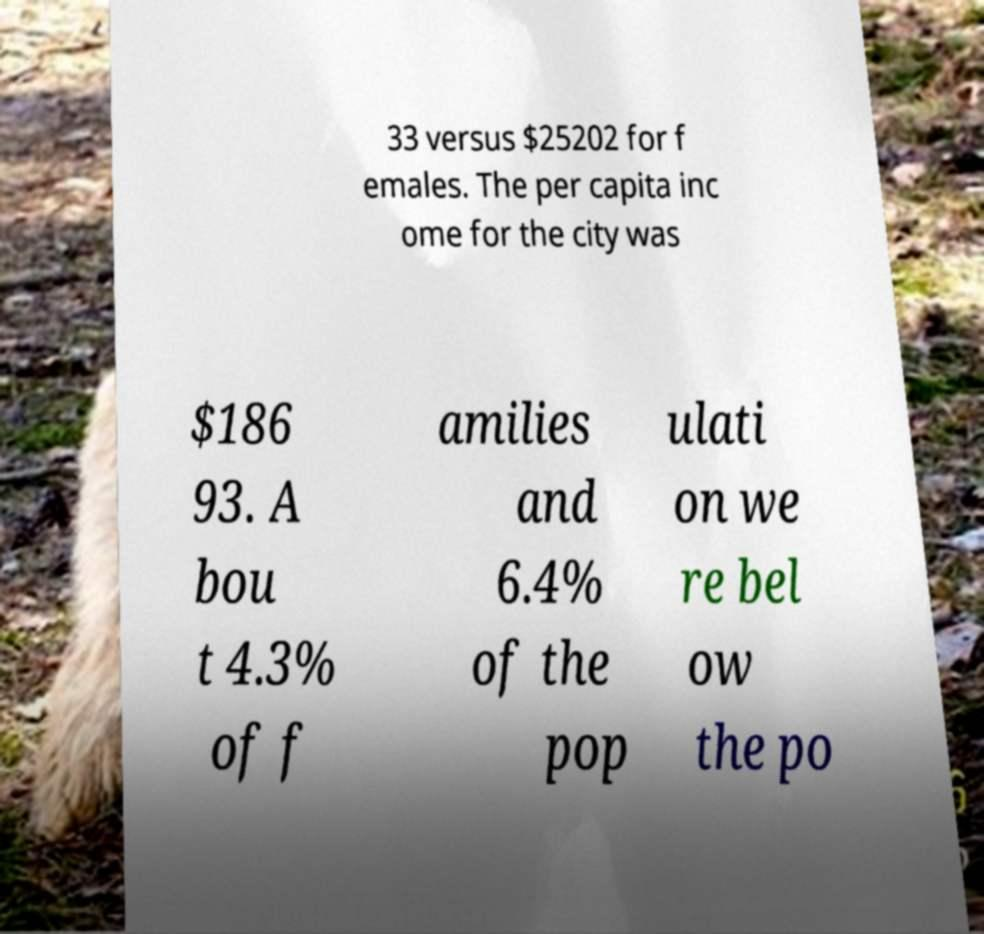Can you read and provide the text displayed in the image?This photo seems to have some interesting text. Can you extract and type it out for me? 33 versus $25202 for f emales. The per capita inc ome for the city was $186 93. A bou t 4.3% of f amilies and 6.4% of the pop ulati on we re bel ow the po 